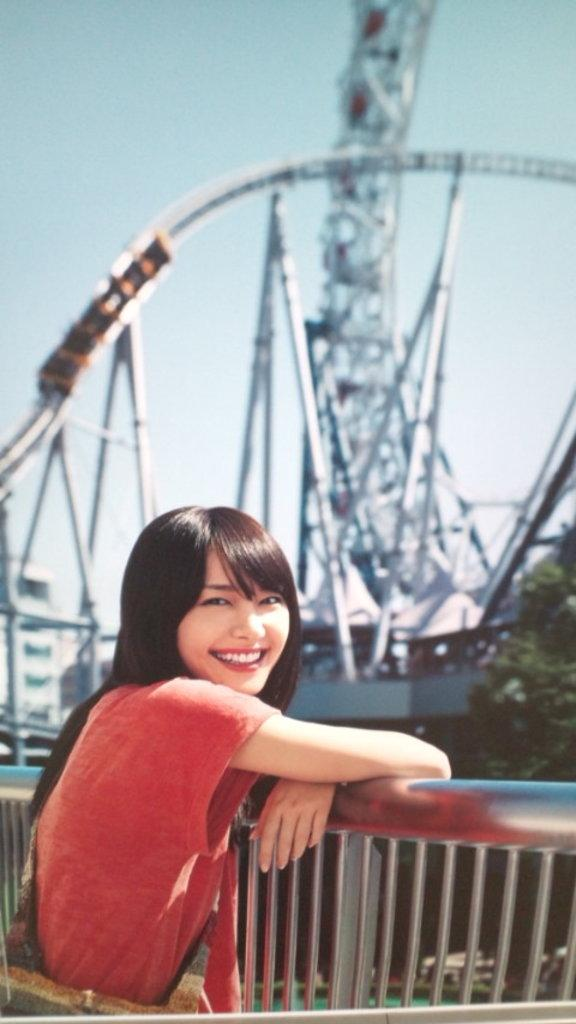Who is present in the image? There is a woman in the image. What is the woman doing in the image? The woman is smiling in the image. Where is the woman located in the image? The woman is standing near grills in the image. What other attractions can be seen in the image? A roller coaster is visible in the image. What type of natural elements are present in the image? There are trees and the sky visible in the image. What type of cream is being used by the fairies in the image? There are no fairies present in the image, so there is no cream being used by them. 